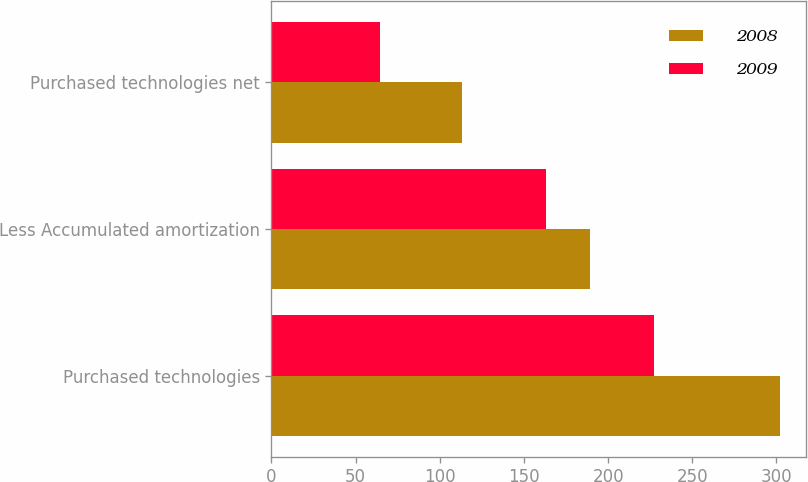<chart> <loc_0><loc_0><loc_500><loc_500><stacked_bar_chart><ecel><fcel>Purchased technologies<fcel>Less Accumulated amortization<fcel>Purchased technologies net<nl><fcel>2008<fcel>302.4<fcel>189.1<fcel>113.3<nl><fcel>2009<fcel>227.5<fcel>163.1<fcel>64.4<nl></chart> 